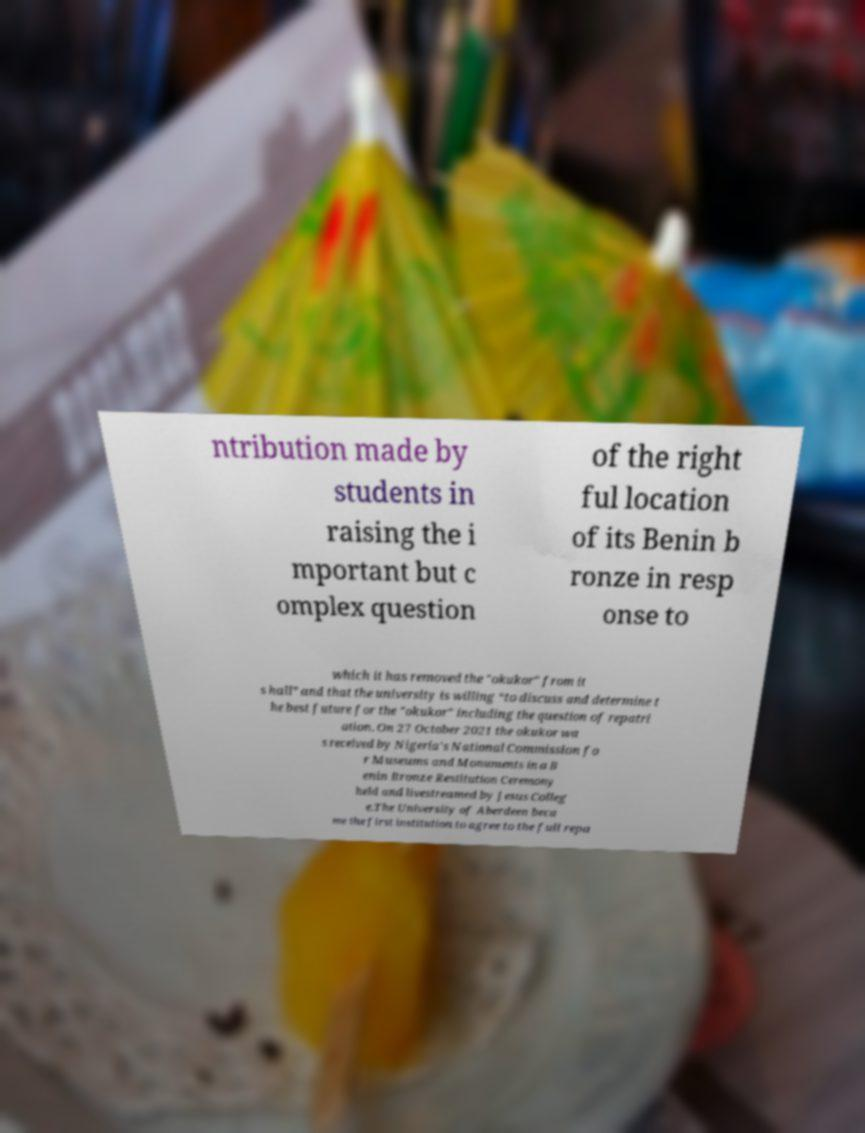Can you accurately transcribe the text from the provided image for me? ntribution made by students in raising the i mportant but c omplex question of the right ful location of its Benin b ronze in resp onse to which it has removed the "okukor" from it s hall” and that the university is willing “to discuss and determine t he best future for the "okukor" including the question of repatri ation. On 27 October 2021 the okukor wa s received by Nigeria's National Commission fo r Museums and Monuments in a B enin Bronze Restitution Ceremony held and livestreamed by Jesus Colleg e.The University of Aberdeen beca me the first institution to agree to the full repa 